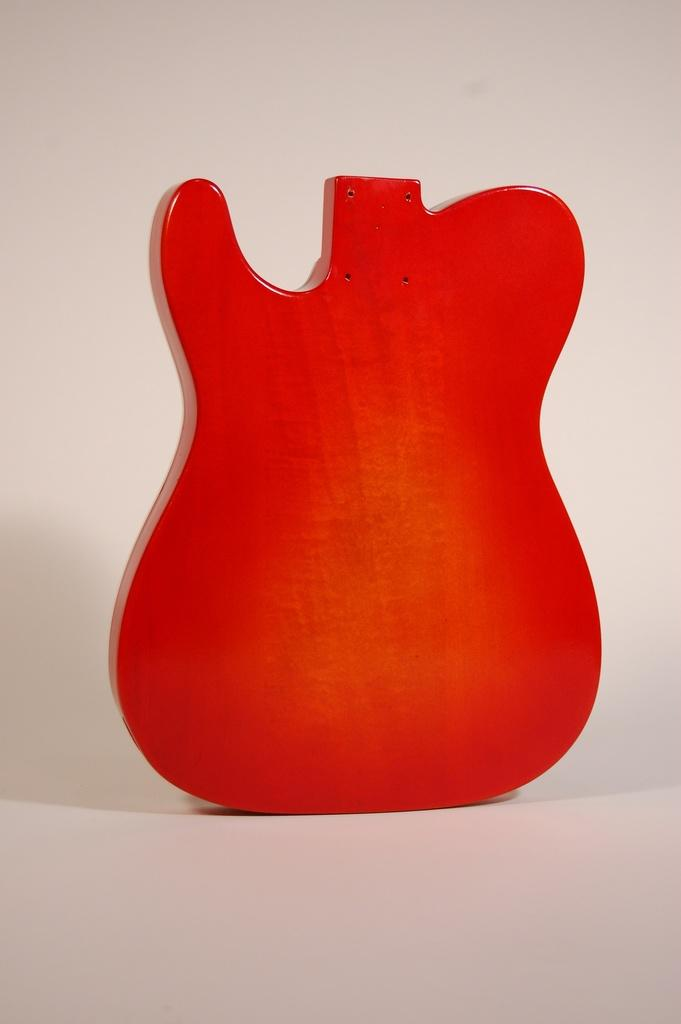What musical instrument is featured in the image? There is a guitar in the image. What color is the guitar? The guitar is red in color. How is the guitar depicted in the image? The guitar is depicted as a half body. How does the force of the guitar increase in the image? There is no force or increase in force depicted in the image; it is a static representation of a guitar. 